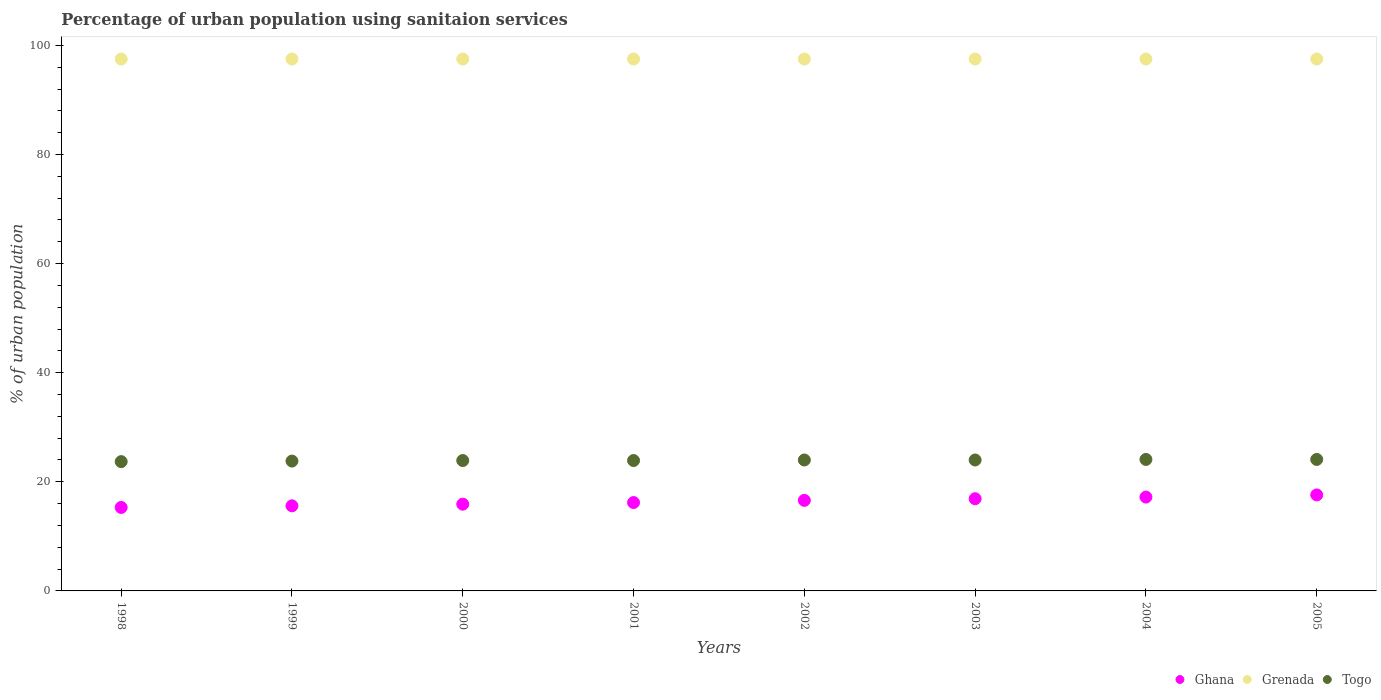What is the percentage of urban population using sanitaion services in Grenada in 2003?
Give a very brief answer. 97.5. Across all years, what is the maximum percentage of urban population using sanitaion services in Togo?
Make the answer very short. 24.1. Across all years, what is the minimum percentage of urban population using sanitaion services in Grenada?
Give a very brief answer. 97.5. In which year was the percentage of urban population using sanitaion services in Grenada minimum?
Your response must be concise. 1998. What is the total percentage of urban population using sanitaion services in Ghana in the graph?
Offer a very short reply. 131.3. What is the difference between the percentage of urban population using sanitaion services in Togo in 2002 and that in 2005?
Give a very brief answer. -0.1. What is the difference between the percentage of urban population using sanitaion services in Grenada in 2004 and the percentage of urban population using sanitaion services in Ghana in 2003?
Your answer should be compact. 80.6. What is the average percentage of urban population using sanitaion services in Grenada per year?
Provide a succinct answer. 97.5. In the year 2000, what is the difference between the percentage of urban population using sanitaion services in Togo and percentage of urban population using sanitaion services in Ghana?
Your answer should be compact. 8. What is the ratio of the percentage of urban population using sanitaion services in Togo in 1998 to that in 2000?
Your response must be concise. 0.99. Is the difference between the percentage of urban population using sanitaion services in Togo in 2000 and 2005 greater than the difference between the percentage of urban population using sanitaion services in Ghana in 2000 and 2005?
Make the answer very short. Yes. What is the difference between the highest and the lowest percentage of urban population using sanitaion services in Ghana?
Make the answer very short. 2.3. Does the percentage of urban population using sanitaion services in Grenada monotonically increase over the years?
Your response must be concise. No. How many dotlines are there?
Make the answer very short. 3. Does the graph contain grids?
Your response must be concise. No. What is the title of the graph?
Your response must be concise. Percentage of urban population using sanitaion services. Does "High income" appear as one of the legend labels in the graph?
Make the answer very short. No. What is the label or title of the X-axis?
Provide a succinct answer. Years. What is the label or title of the Y-axis?
Provide a short and direct response. % of urban population. What is the % of urban population in Ghana in 1998?
Provide a succinct answer. 15.3. What is the % of urban population in Grenada in 1998?
Provide a short and direct response. 97.5. What is the % of urban population of Togo in 1998?
Your response must be concise. 23.7. What is the % of urban population in Grenada in 1999?
Make the answer very short. 97.5. What is the % of urban population in Togo in 1999?
Your response must be concise. 23.8. What is the % of urban population of Grenada in 2000?
Ensure brevity in your answer.  97.5. What is the % of urban population in Togo in 2000?
Make the answer very short. 23.9. What is the % of urban population of Grenada in 2001?
Keep it short and to the point. 97.5. What is the % of urban population of Togo in 2001?
Keep it short and to the point. 23.9. What is the % of urban population of Ghana in 2002?
Keep it short and to the point. 16.6. What is the % of urban population in Grenada in 2002?
Ensure brevity in your answer.  97.5. What is the % of urban population of Ghana in 2003?
Your answer should be very brief. 16.9. What is the % of urban population in Grenada in 2003?
Keep it short and to the point. 97.5. What is the % of urban population in Togo in 2003?
Make the answer very short. 24. What is the % of urban population in Ghana in 2004?
Give a very brief answer. 17.2. What is the % of urban population in Grenada in 2004?
Offer a very short reply. 97.5. What is the % of urban population of Togo in 2004?
Your answer should be compact. 24.1. What is the % of urban population of Ghana in 2005?
Offer a terse response. 17.6. What is the % of urban population of Grenada in 2005?
Provide a short and direct response. 97.5. What is the % of urban population of Togo in 2005?
Make the answer very short. 24.1. Across all years, what is the maximum % of urban population in Grenada?
Give a very brief answer. 97.5. Across all years, what is the maximum % of urban population of Togo?
Your answer should be compact. 24.1. Across all years, what is the minimum % of urban population in Ghana?
Your answer should be compact. 15.3. Across all years, what is the minimum % of urban population in Grenada?
Your answer should be very brief. 97.5. Across all years, what is the minimum % of urban population in Togo?
Give a very brief answer. 23.7. What is the total % of urban population of Ghana in the graph?
Offer a very short reply. 131.3. What is the total % of urban population of Grenada in the graph?
Make the answer very short. 780. What is the total % of urban population of Togo in the graph?
Your answer should be very brief. 191.5. What is the difference between the % of urban population of Ghana in 1998 and that in 2000?
Make the answer very short. -0.6. What is the difference between the % of urban population in Grenada in 1998 and that in 2000?
Provide a succinct answer. 0. What is the difference between the % of urban population in Togo in 1998 and that in 2000?
Provide a succinct answer. -0.2. What is the difference between the % of urban population in Grenada in 1998 and that in 2001?
Your answer should be compact. 0. What is the difference between the % of urban population of Togo in 1998 and that in 2001?
Your answer should be very brief. -0.2. What is the difference between the % of urban population in Ghana in 1998 and that in 2004?
Provide a succinct answer. -1.9. What is the difference between the % of urban population of Togo in 1998 and that in 2004?
Your answer should be very brief. -0.4. What is the difference between the % of urban population of Ghana in 1998 and that in 2005?
Your response must be concise. -2.3. What is the difference between the % of urban population in Togo in 1998 and that in 2005?
Your answer should be very brief. -0.4. What is the difference between the % of urban population in Ghana in 1999 and that in 2000?
Give a very brief answer. -0.3. What is the difference between the % of urban population in Togo in 1999 and that in 2000?
Provide a short and direct response. -0.1. What is the difference between the % of urban population in Ghana in 1999 and that in 2001?
Your answer should be very brief. -0.6. What is the difference between the % of urban population of Grenada in 1999 and that in 2001?
Your answer should be compact. 0. What is the difference between the % of urban population in Ghana in 1999 and that in 2002?
Your answer should be compact. -1. What is the difference between the % of urban population in Grenada in 1999 and that in 2002?
Offer a terse response. 0. What is the difference between the % of urban population of Togo in 1999 and that in 2002?
Make the answer very short. -0.2. What is the difference between the % of urban population of Togo in 1999 and that in 2003?
Provide a short and direct response. -0.2. What is the difference between the % of urban population of Ghana in 1999 and that in 2004?
Make the answer very short. -1.6. What is the difference between the % of urban population in Grenada in 1999 and that in 2004?
Your response must be concise. 0. What is the difference between the % of urban population of Togo in 1999 and that in 2004?
Your answer should be very brief. -0.3. What is the difference between the % of urban population in Ghana in 1999 and that in 2005?
Make the answer very short. -2. What is the difference between the % of urban population of Ghana in 2000 and that in 2001?
Your response must be concise. -0.3. What is the difference between the % of urban population of Grenada in 2000 and that in 2001?
Provide a short and direct response. 0. What is the difference between the % of urban population of Togo in 2000 and that in 2001?
Offer a very short reply. 0. What is the difference between the % of urban population in Togo in 2000 and that in 2003?
Your response must be concise. -0.1. What is the difference between the % of urban population in Ghana in 2000 and that in 2005?
Make the answer very short. -1.7. What is the difference between the % of urban population in Grenada in 2001 and that in 2002?
Ensure brevity in your answer.  0. What is the difference between the % of urban population of Togo in 2001 and that in 2002?
Ensure brevity in your answer.  -0.1. What is the difference between the % of urban population of Ghana in 2001 and that in 2003?
Offer a very short reply. -0.7. What is the difference between the % of urban population of Grenada in 2001 and that in 2003?
Your answer should be very brief. 0. What is the difference between the % of urban population of Grenada in 2001 and that in 2004?
Provide a short and direct response. 0. What is the difference between the % of urban population in Togo in 2001 and that in 2005?
Ensure brevity in your answer.  -0.2. What is the difference between the % of urban population in Ghana in 2002 and that in 2004?
Keep it short and to the point. -0.6. What is the difference between the % of urban population of Grenada in 2002 and that in 2005?
Provide a succinct answer. 0. What is the difference between the % of urban population in Grenada in 2003 and that in 2004?
Your answer should be very brief. 0. What is the difference between the % of urban population in Togo in 2003 and that in 2004?
Offer a very short reply. -0.1. What is the difference between the % of urban population of Grenada in 2003 and that in 2005?
Your answer should be very brief. 0. What is the difference between the % of urban population of Ghana in 2004 and that in 2005?
Your answer should be very brief. -0.4. What is the difference between the % of urban population of Togo in 2004 and that in 2005?
Provide a succinct answer. 0. What is the difference between the % of urban population in Ghana in 1998 and the % of urban population in Grenada in 1999?
Give a very brief answer. -82.2. What is the difference between the % of urban population of Ghana in 1998 and the % of urban population of Togo in 1999?
Your answer should be compact. -8.5. What is the difference between the % of urban population of Grenada in 1998 and the % of urban population of Togo in 1999?
Provide a succinct answer. 73.7. What is the difference between the % of urban population of Ghana in 1998 and the % of urban population of Grenada in 2000?
Your answer should be compact. -82.2. What is the difference between the % of urban population of Grenada in 1998 and the % of urban population of Togo in 2000?
Ensure brevity in your answer.  73.6. What is the difference between the % of urban population of Ghana in 1998 and the % of urban population of Grenada in 2001?
Your answer should be compact. -82.2. What is the difference between the % of urban population of Grenada in 1998 and the % of urban population of Togo in 2001?
Offer a very short reply. 73.6. What is the difference between the % of urban population in Ghana in 1998 and the % of urban population in Grenada in 2002?
Ensure brevity in your answer.  -82.2. What is the difference between the % of urban population in Grenada in 1998 and the % of urban population in Togo in 2002?
Give a very brief answer. 73.5. What is the difference between the % of urban population of Ghana in 1998 and the % of urban population of Grenada in 2003?
Your answer should be compact. -82.2. What is the difference between the % of urban population in Ghana in 1998 and the % of urban population in Togo in 2003?
Make the answer very short. -8.7. What is the difference between the % of urban population of Grenada in 1998 and the % of urban population of Togo in 2003?
Your answer should be compact. 73.5. What is the difference between the % of urban population in Ghana in 1998 and the % of urban population in Grenada in 2004?
Keep it short and to the point. -82.2. What is the difference between the % of urban population in Ghana in 1998 and the % of urban population in Togo in 2004?
Your response must be concise. -8.8. What is the difference between the % of urban population of Grenada in 1998 and the % of urban population of Togo in 2004?
Offer a terse response. 73.4. What is the difference between the % of urban population in Ghana in 1998 and the % of urban population in Grenada in 2005?
Your answer should be compact. -82.2. What is the difference between the % of urban population of Ghana in 1998 and the % of urban population of Togo in 2005?
Ensure brevity in your answer.  -8.8. What is the difference between the % of urban population in Grenada in 1998 and the % of urban population in Togo in 2005?
Provide a succinct answer. 73.4. What is the difference between the % of urban population of Ghana in 1999 and the % of urban population of Grenada in 2000?
Ensure brevity in your answer.  -81.9. What is the difference between the % of urban population in Grenada in 1999 and the % of urban population in Togo in 2000?
Your answer should be very brief. 73.6. What is the difference between the % of urban population in Ghana in 1999 and the % of urban population in Grenada in 2001?
Keep it short and to the point. -81.9. What is the difference between the % of urban population of Grenada in 1999 and the % of urban population of Togo in 2001?
Ensure brevity in your answer.  73.6. What is the difference between the % of urban population of Ghana in 1999 and the % of urban population of Grenada in 2002?
Offer a very short reply. -81.9. What is the difference between the % of urban population in Ghana in 1999 and the % of urban population in Togo in 2002?
Your answer should be very brief. -8.4. What is the difference between the % of urban population of Grenada in 1999 and the % of urban population of Togo in 2002?
Your response must be concise. 73.5. What is the difference between the % of urban population of Ghana in 1999 and the % of urban population of Grenada in 2003?
Give a very brief answer. -81.9. What is the difference between the % of urban population in Ghana in 1999 and the % of urban population in Togo in 2003?
Your response must be concise. -8.4. What is the difference between the % of urban population of Grenada in 1999 and the % of urban population of Togo in 2003?
Offer a terse response. 73.5. What is the difference between the % of urban population in Ghana in 1999 and the % of urban population in Grenada in 2004?
Your answer should be very brief. -81.9. What is the difference between the % of urban population in Ghana in 1999 and the % of urban population in Togo in 2004?
Your answer should be compact. -8.5. What is the difference between the % of urban population of Grenada in 1999 and the % of urban population of Togo in 2004?
Offer a very short reply. 73.4. What is the difference between the % of urban population of Ghana in 1999 and the % of urban population of Grenada in 2005?
Make the answer very short. -81.9. What is the difference between the % of urban population in Ghana in 1999 and the % of urban population in Togo in 2005?
Give a very brief answer. -8.5. What is the difference between the % of urban population of Grenada in 1999 and the % of urban population of Togo in 2005?
Your response must be concise. 73.4. What is the difference between the % of urban population in Ghana in 2000 and the % of urban population in Grenada in 2001?
Offer a terse response. -81.6. What is the difference between the % of urban population in Ghana in 2000 and the % of urban population in Togo in 2001?
Keep it short and to the point. -8. What is the difference between the % of urban population in Grenada in 2000 and the % of urban population in Togo in 2001?
Keep it short and to the point. 73.6. What is the difference between the % of urban population of Ghana in 2000 and the % of urban population of Grenada in 2002?
Your answer should be very brief. -81.6. What is the difference between the % of urban population of Ghana in 2000 and the % of urban population of Togo in 2002?
Your response must be concise. -8.1. What is the difference between the % of urban population in Grenada in 2000 and the % of urban population in Togo in 2002?
Provide a succinct answer. 73.5. What is the difference between the % of urban population in Ghana in 2000 and the % of urban population in Grenada in 2003?
Keep it short and to the point. -81.6. What is the difference between the % of urban population in Ghana in 2000 and the % of urban population in Togo in 2003?
Your response must be concise. -8.1. What is the difference between the % of urban population of Grenada in 2000 and the % of urban population of Togo in 2003?
Give a very brief answer. 73.5. What is the difference between the % of urban population in Ghana in 2000 and the % of urban population in Grenada in 2004?
Provide a succinct answer. -81.6. What is the difference between the % of urban population in Ghana in 2000 and the % of urban population in Togo in 2004?
Provide a succinct answer. -8.2. What is the difference between the % of urban population of Grenada in 2000 and the % of urban population of Togo in 2004?
Ensure brevity in your answer.  73.4. What is the difference between the % of urban population in Ghana in 2000 and the % of urban population in Grenada in 2005?
Offer a very short reply. -81.6. What is the difference between the % of urban population in Ghana in 2000 and the % of urban population in Togo in 2005?
Offer a terse response. -8.2. What is the difference between the % of urban population of Grenada in 2000 and the % of urban population of Togo in 2005?
Provide a succinct answer. 73.4. What is the difference between the % of urban population in Ghana in 2001 and the % of urban population in Grenada in 2002?
Give a very brief answer. -81.3. What is the difference between the % of urban population in Grenada in 2001 and the % of urban population in Togo in 2002?
Give a very brief answer. 73.5. What is the difference between the % of urban population of Ghana in 2001 and the % of urban population of Grenada in 2003?
Offer a very short reply. -81.3. What is the difference between the % of urban population in Ghana in 2001 and the % of urban population in Togo in 2003?
Your response must be concise. -7.8. What is the difference between the % of urban population in Grenada in 2001 and the % of urban population in Togo in 2003?
Keep it short and to the point. 73.5. What is the difference between the % of urban population in Ghana in 2001 and the % of urban population in Grenada in 2004?
Offer a terse response. -81.3. What is the difference between the % of urban population in Grenada in 2001 and the % of urban population in Togo in 2004?
Make the answer very short. 73.4. What is the difference between the % of urban population in Ghana in 2001 and the % of urban population in Grenada in 2005?
Provide a succinct answer. -81.3. What is the difference between the % of urban population in Grenada in 2001 and the % of urban population in Togo in 2005?
Offer a terse response. 73.4. What is the difference between the % of urban population of Ghana in 2002 and the % of urban population of Grenada in 2003?
Give a very brief answer. -80.9. What is the difference between the % of urban population of Grenada in 2002 and the % of urban population of Togo in 2003?
Your answer should be very brief. 73.5. What is the difference between the % of urban population of Ghana in 2002 and the % of urban population of Grenada in 2004?
Your response must be concise. -80.9. What is the difference between the % of urban population in Ghana in 2002 and the % of urban population in Togo in 2004?
Provide a short and direct response. -7.5. What is the difference between the % of urban population in Grenada in 2002 and the % of urban population in Togo in 2004?
Keep it short and to the point. 73.4. What is the difference between the % of urban population in Ghana in 2002 and the % of urban population in Grenada in 2005?
Make the answer very short. -80.9. What is the difference between the % of urban population of Ghana in 2002 and the % of urban population of Togo in 2005?
Your response must be concise. -7.5. What is the difference between the % of urban population of Grenada in 2002 and the % of urban population of Togo in 2005?
Your answer should be very brief. 73.4. What is the difference between the % of urban population in Ghana in 2003 and the % of urban population in Grenada in 2004?
Offer a terse response. -80.6. What is the difference between the % of urban population in Ghana in 2003 and the % of urban population in Togo in 2004?
Offer a terse response. -7.2. What is the difference between the % of urban population in Grenada in 2003 and the % of urban population in Togo in 2004?
Your response must be concise. 73.4. What is the difference between the % of urban population in Ghana in 2003 and the % of urban population in Grenada in 2005?
Give a very brief answer. -80.6. What is the difference between the % of urban population in Ghana in 2003 and the % of urban population in Togo in 2005?
Keep it short and to the point. -7.2. What is the difference between the % of urban population of Grenada in 2003 and the % of urban population of Togo in 2005?
Your response must be concise. 73.4. What is the difference between the % of urban population of Ghana in 2004 and the % of urban population of Grenada in 2005?
Your answer should be very brief. -80.3. What is the difference between the % of urban population in Ghana in 2004 and the % of urban population in Togo in 2005?
Offer a very short reply. -6.9. What is the difference between the % of urban population of Grenada in 2004 and the % of urban population of Togo in 2005?
Give a very brief answer. 73.4. What is the average % of urban population of Ghana per year?
Offer a very short reply. 16.41. What is the average % of urban population in Grenada per year?
Give a very brief answer. 97.5. What is the average % of urban population in Togo per year?
Provide a succinct answer. 23.94. In the year 1998, what is the difference between the % of urban population of Ghana and % of urban population of Grenada?
Your answer should be compact. -82.2. In the year 1998, what is the difference between the % of urban population of Ghana and % of urban population of Togo?
Make the answer very short. -8.4. In the year 1998, what is the difference between the % of urban population of Grenada and % of urban population of Togo?
Give a very brief answer. 73.8. In the year 1999, what is the difference between the % of urban population in Ghana and % of urban population in Grenada?
Your response must be concise. -81.9. In the year 1999, what is the difference between the % of urban population in Grenada and % of urban population in Togo?
Provide a short and direct response. 73.7. In the year 2000, what is the difference between the % of urban population of Ghana and % of urban population of Grenada?
Your response must be concise. -81.6. In the year 2000, what is the difference between the % of urban population of Grenada and % of urban population of Togo?
Your answer should be compact. 73.6. In the year 2001, what is the difference between the % of urban population in Ghana and % of urban population in Grenada?
Keep it short and to the point. -81.3. In the year 2001, what is the difference between the % of urban population in Grenada and % of urban population in Togo?
Your answer should be very brief. 73.6. In the year 2002, what is the difference between the % of urban population of Ghana and % of urban population of Grenada?
Your answer should be compact. -80.9. In the year 2002, what is the difference between the % of urban population of Grenada and % of urban population of Togo?
Your answer should be very brief. 73.5. In the year 2003, what is the difference between the % of urban population in Ghana and % of urban population in Grenada?
Offer a very short reply. -80.6. In the year 2003, what is the difference between the % of urban population in Ghana and % of urban population in Togo?
Your answer should be very brief. -7.1. In the year 2003, what is the difference between the % of urban population in Grenada and % of urban population in Togo?
Provide a short and direct response. 73.5. In the year 2004, what is the difference between the % of urban population of Ghana and % of urban population of Grenada?
Your answer should be very brief. -80.3. In the year 2004, what is the difference between the % of urban population of Ghana and % of urban population of Togo?
Give a very brief answer. -6.9. In the year 2004, what is the difference between the % of urban population of Grenada and % of urban population of Togo?
Offer a terse response. 73.4. In the year 2005, what is the difference between the % of urban population in Ghana and % of urban population in Grenada?
Offer a terse response. -79.9. In the year 2005, what is the difference between the % of urban population of Ghana and % of urban population of Togo?
Your answer should be very brief. -6.5. In the year 2005, what is the difference between the % of urban population in Grenada and % of urban population in Togo?
Your answer should be compact. 73.4. What is the ratio of the % of urban population in Ghana in 1998 to that in 1999?
Offer a very short reply. 0.98. What is the ratio of the % of urban population in Ghana in 1998 to that in 2000?
Keep it short and to the point. 0.96. What is the ratio of the % of urban population in Grenada in 1998 to that in 2000?
Ensure brevity in your answer.  1. What is the ratio of the % of urban population in Ghana in 1998 to that in 2001?
Your response must be concise. 0.94. What is the ratio of the % of urban population in Ghana in 1998 to that in 2002?
Provide a short and direct response. 0.92. What is the ratio of the % of urban population of Togo in 1998 to that in 2002?
Give a very brief answer. 0.99. What is the ratio of the % of urban population of Ghana in 1998 to that in 2003?
Offer a terse response. 0.91. What is the ratio of the % of urban population in Togo in 1998 to that in 2003?
Your answer should be very brief. 0.99. What is the ratio of the % of urban population of Ghana in 1998 to that in 2004?
Provide a succinct answer. 0.89. What is the ratio of the % of urban population of Grenada in 1998 to that in 2004?
Your answer should be very brief. 1. What is the ratio of the % of urban population of Togo in 1998 to that in 2004?
Your answer should be very brief. 0.98. What is the ratio of the % of urban population in Ghana in 1998 to that in 2005?
Your response must be concise. 0.87. What is the ratio of the % of urban population in Togo in 1998 to that in 2005?
Your answer should be very brief. 0.98. What is the ratio of the % of urban population of Ghana in 1999 to that in 2000?
Provide a succinct answer. 0.98. What is the ratio of the % of urban population of Ghana in 1999 to that in 2001?
Offer a terse response. 0.96. What is the ratio of the % of urban population of Togo in 1999 to that in 2001?
Give a very brief answer. 1. What is the ratio of the % of urban population of Ghana in 1999 to that in 2002?
Make the answer very short. 0.94. What is the ratio of the % of urban population of Togo in 1999 to that in 2002?
Your answer should be very brief. 0.99. What is the ratio of the % of urban population of Ghana in 1999 to that in 2004?
Your response must be concise. 0.91. What is the ratio of the % of urban population in Grenada in 1999 to that in 2004?
Give a very brief answer. 1. What is the ratio of the % of urban population in Togo in 1999 to that in 2004?
Keep it short and to the point. 0.99. What is the ratio of the % of urban population in Ghana in 1999 to that in 2005?
Provide a succinct answer. 0.89. What is the ratio of the % of urban population in Grenada in 1999 to that in 2005?
Give a very brief answer. 1. What is the ratio of the % of urban population in Togo in 1999 to that in 2005?
Your response must be concise. 0.99. What is the ratio of the % of urban population in Ghana in 2000 to that in 2001?
Ensure brevity in your answer.  0.98. What is the ratio of the % of urban population in Togo in 2000 to that in 2001?
Give a very brief answer. 1. What is the ratio of the % of urban population in Ghana in 2000 to that in 2002?
Provide a succinct answer. 0.96. What is the ratio of the % of urban population in Grenada in 2000 to that in 2002?
Your answer should be compact. 1. What is the ratio of the % of urban population of Ghana in 2000 to that in 2003?
Offer a very short reply. 0.94. What is the ratio of the % of urban population of Togo in 2000 to that in 2003?
Offer a terse response. 1. What is the ratio of the % of urban population in Ghana in 2000 to that in 2004?
Provide a short and direct response. 0.92. What is the ratio of the % of urban population of Ghana in 2000 to that in 2005?
Give a very brief answer. 0.9. What is the ratio of the % of urban population in Grenada in 2000 to that in 2005?
Keep it short and to the point. 1. What is the ratio of the % of urban population in Ghana in 2001 to that in 2002?
Provide a succinct answer. 0.98. What is the ratio of the % of urban population of Ghana in 2001 to that in 2003?
Your answer should be compact. 0.96. What is the ratio of the % of urban population in Togo in 2001 to that in 2003?
Your answer should be compact. 1. What is the ratio of the % of urban population of Ghana in 2001 to that in 2004?
Ensure brevity in your answer.  0.94. What is the ratio of the % of urban population in Grenada in 2001 to that in 2004?
Give a very brief answer. 1. What is the ratio of the % of urban population of Togo in 2001 to that in 2004?
Your answer should be very brief. 0.99. What is the ratio of the % of urban population of Ghana in 2001 to that in 2005?
Offer a terse response. 0.92. What is the ratio of the % of urban population of Grenada in 2001 to that in 2005?
Provide a succinct answer. 1. What is the ratio of the % of urban population of Ghana in 2002 to that in 2003?
Offer a very short reply. 0.98. What is the ratio of the % of urban population of Ghana in 2002 to that in 2004?
Offer a terse response. 0.97. What is the ratio of the % of urban population in Togo in 2002 to that in 2004?
Offer a very short reply. 1. What is the ratio of the % of urban population of Ghana in 2002 to that in 2005?
Your response must be concise. 0.94. What is the ratio of the % of urban population in Grenada in 2002 to that in 2005?
Ensure brevity in your answer.  1. What is the ratio of the % of urban population in Togo in 2002 to that in 2005?
Provide a short and direct response. 1. What is the ratio of the % of urban population of Ghana in 2003 to that in 2004?
Ensure brevity in your answer.  0.98. What is the ratio of the % of urban population in Togo in 2003 to that in 2004?
Ensure brevity in your answer.  1. What is the ratio of the % of urban population in Ghana in 2003 to that in 2005?
Your response must be concise. 0.96. What is the ratio of the % of urban population in Togo in 2003 to that in 2005?
Provide a succinct answer. 1. What is the ratio of the % of urban population in Ghana in 2004 to that in 2005?
Give a very brief answer. 0.98. What is the ratio of the % of urban population in Grenada in 2004 to that in 2005?
Keep it short and to the point. 1. What is the ratio of the % of urban population in Togo in 2004 to that in 2005?
Provide a short and direct response. 1. What is the difference between the highest and the second highest % of urban population in Ghana?
Your response must be concise. 0.4. What is the difference between the highest and the second highest % of urban population of Grenada?
Your response must be concise. 0. What is the difference between the highest and the second highest % of urban population of Togo?
Your answer should be very brief. 0. What is the difference between the highest and the lowest % of urban population of Grenada?
Make the answer very short. 0. 